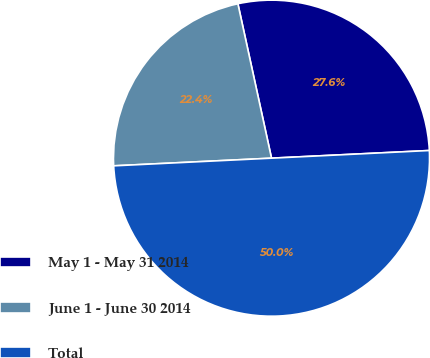Convert chart. <chart><loc_0><loc_0><loc_500><loc_500><pie_chart><fcel>May 1 - May 31 2014<fcel>June 1 - June 30 2014<fcel>Total<nl><fcel>27.64%<fcel>22.36%<fcel>50.0%<nl></chart> 